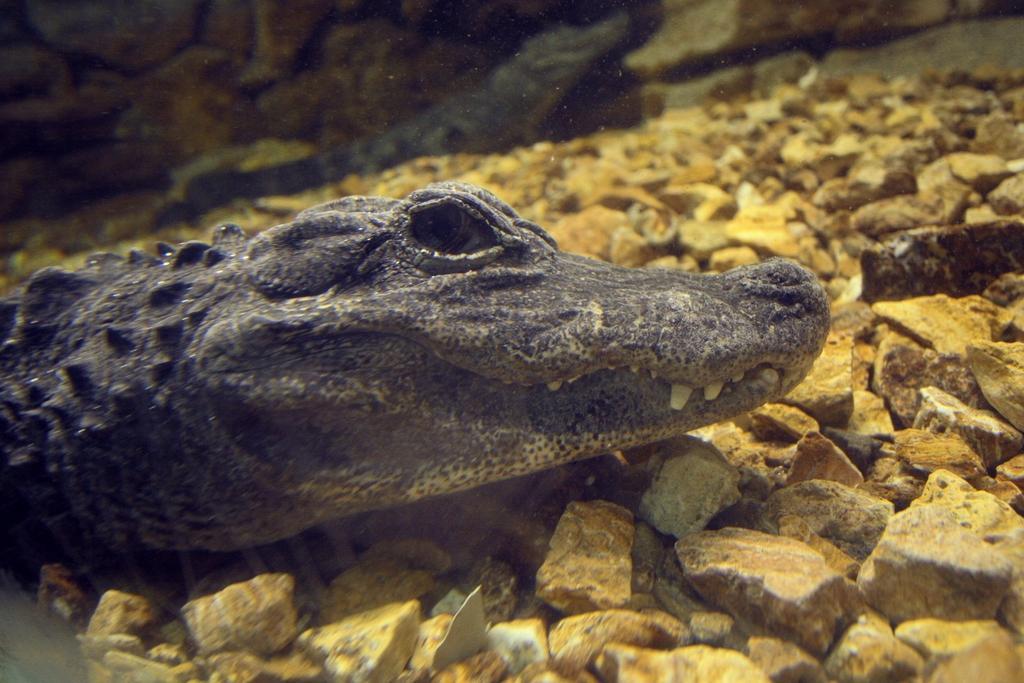Could you give a brief overview of what you see in this image? In this image there is a crocodile on the stones. 